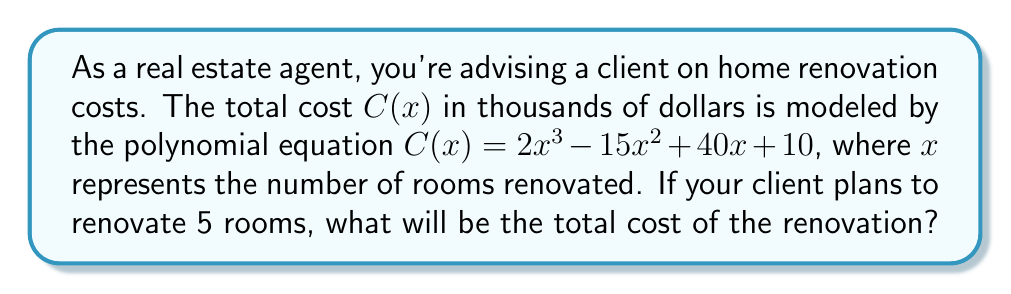Provide a solution to this math problem. To find the total cost of renovating 5 rooms, we need to evaluate the polynomial function C(x) at x = 5.

Given: $C(x) = 2x^3 - 15x^2 + 40x + 10$

Step 1: Substitute x = 5 into the equation.
$C(5) = 2(5)^3 - 15(5)^2 + 40(5) + 10$

Step 2: Calculate the powers.
$C(5) = 2(125) - 15(25) + 40(5) + 10$

Step 3: Multiply the terms.
$C(5) = 250 - 375 + 200 + 10$

Step 4: Add the terms.
$C(5) = 85$

Since C(x) is in thousands of dollars, the total cost is $85,000.
Answer: $85,000 